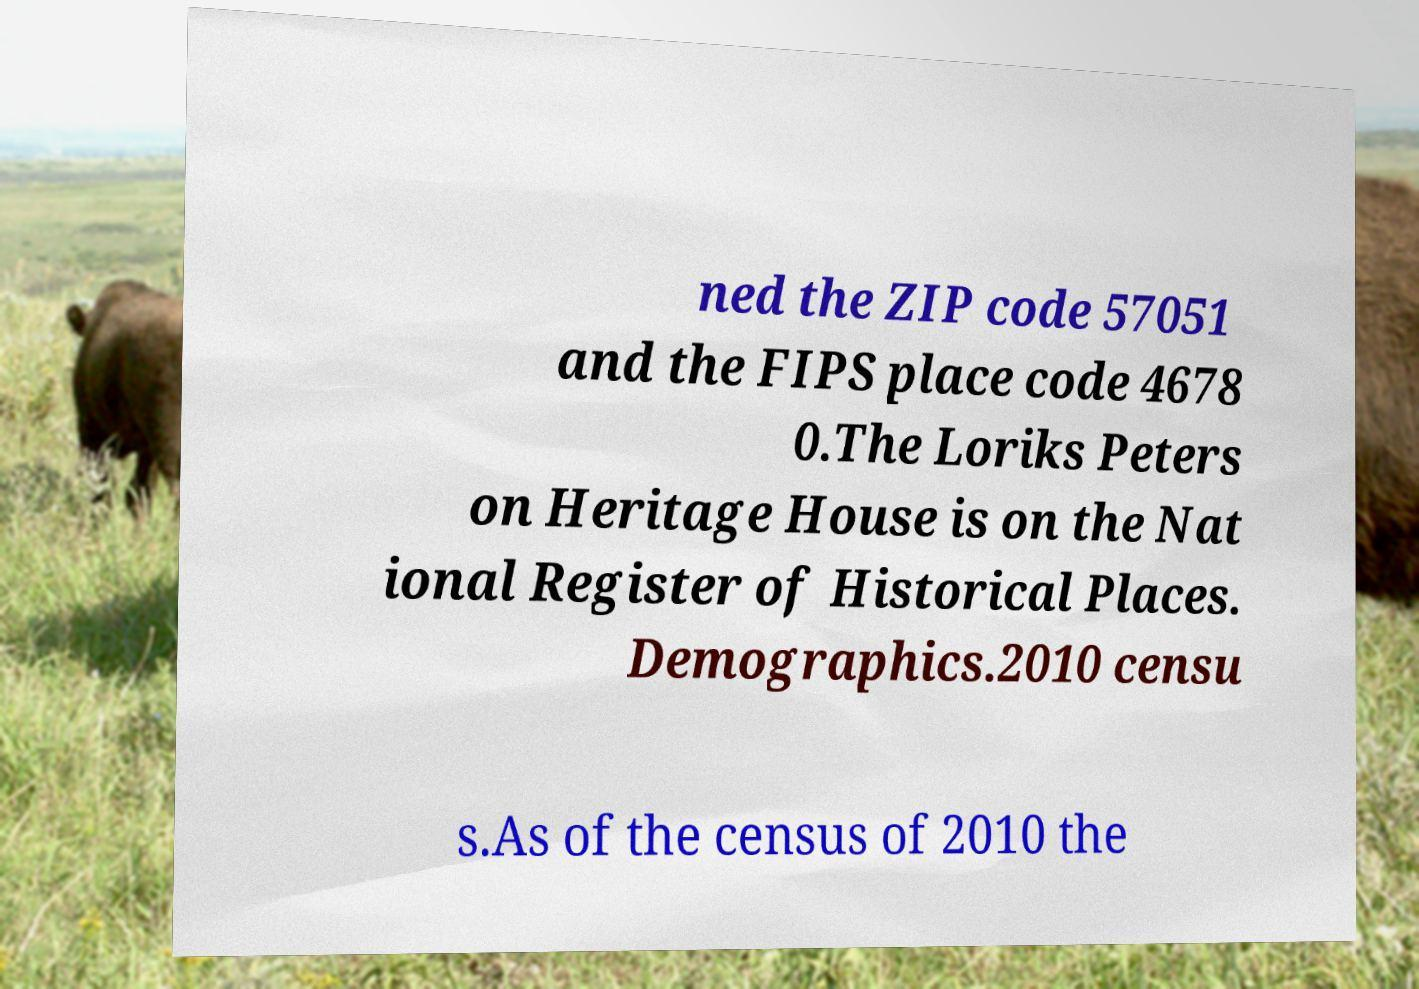Could you assist in decoding the text presented in this image and type it out clearly? ned the ZIP code 57051 and the FIPS place code 4678 0.The Loriks Peters on Heritage House is on the Nat ional Register of Historical Places. Demographics.2010 censu s.As of the census of 2010 the 